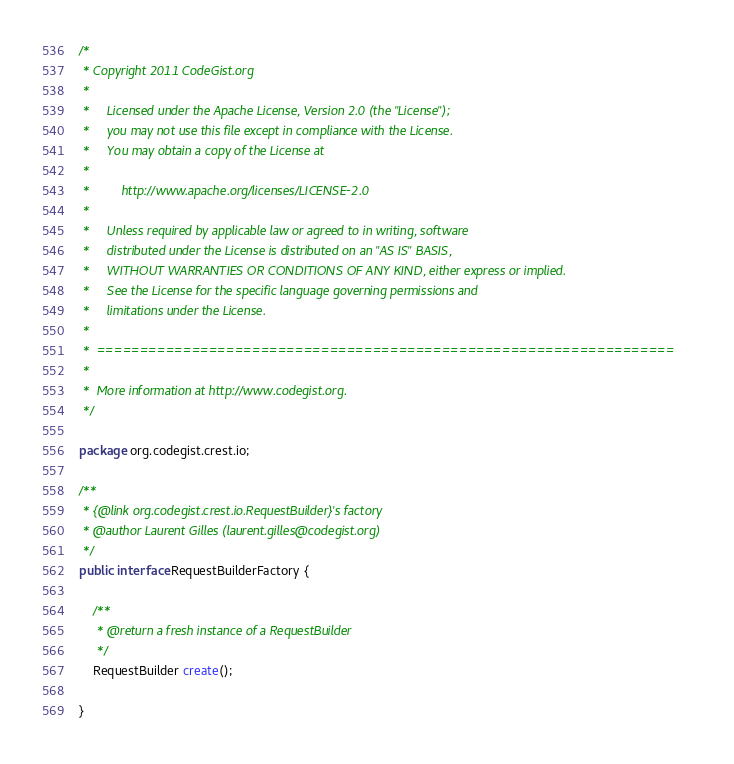<code> <loc_0><loc_0><loc_500><loc_500><_Java_>/*
 * Copyright 2011 CodeGist.org
 *
 *     Licensed under the Apache License, Version 2.0 (the "License");
 *     you may not use this file except in compliance with the License.
 *     You may obtain a copy of the License at
 *
 *         http://www.apache.org/licenses/LICENSE-2.0
 *
 *     Unless required by applicable law or agreed to in writing, software
 *     distributed under the License is distributed on an "AS IS" BASIS,
 *     WITHOUT WARRANTIES OR CONDITIONS OF ANY KIND, either express or implied.
 *     See the License for the specific language governing permissions and
 *     limitations under the License.
 *
 *  ===================================================================
 *
 *  More information at http://www.codegist.org.
 */

package org.codegist.crest.io;

/**
 * {@link org.codegist.crest.io.RequestBuilder}'s factory
 * @author Laurent Gilles (laurent.gilles@codegist.org)
 */
public interface RequestBuilderFactory {

    /**
     * @return a fresh instance of a RequestBuilder
     */
    RequestBuilder create();

}
</code> 